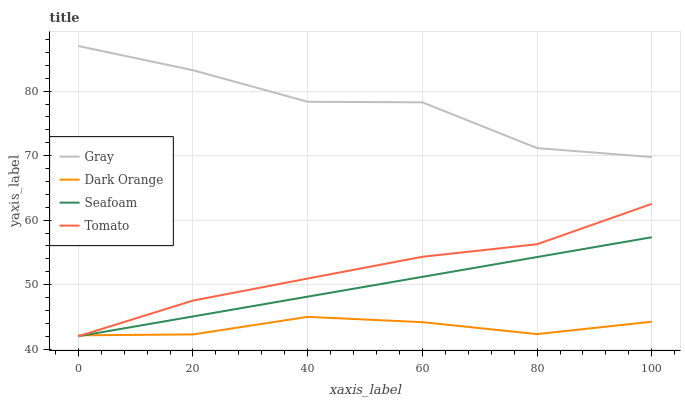Does Dark Orange have the minimum area under the curve?
Answer yes or no. Yes. Does Gray have the maximum area under the curve?
Answer yes or no. Yes. Does Seafoam have the minimum area under the curve?
Answer yes or no. No. Does Seafoam have the maximum area under the curve?
Answer yes or no. No. Is Seafoam the smoothest?
Answer yes or no. Yes. Is Gray the roughest?
Answer yes or no. Yes. Is Gray the smoothest?
Answer yes or no. No. Is Seafoam the roughest?
Answer yes or no. No. Does Tomato have the lowest value?
Answer yes or no. Yes. Does Gray have the lowest value?
Answer yes or no. No. Does Gray have the highest value?
Answer yes or no. Yes. Does Seafoam have the highest value?
Answer yes or no. No. Is Seafoam less than Gray?
Answer yes or no. Yes. Is Gray greater than Seafoam?
Answer yes or no. Yes. Does Tomato intersect Dark Orange?
Answer yes or no. Yes. Is Tomato less than Dark Orange?
Answer yes or no. No. Is Tomato greater than Dark Orange?
Answer yes or no. No. Does Seafoam intersect Gray?
Answer yes or no. No. 